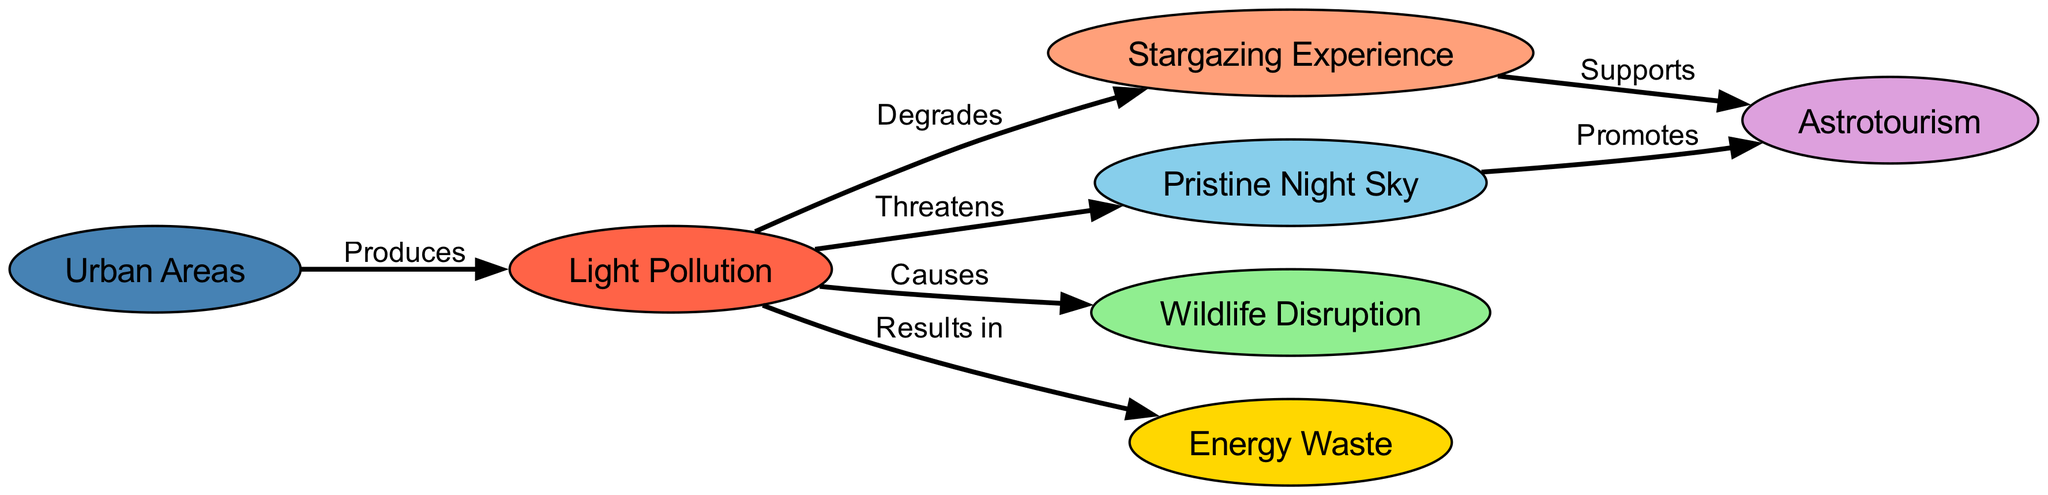What produces light pollution? The diagram indicates that urban areas produce light pollution, as depicted by the directed edge from "urban_areas" to "light_pollution."
Answer: Urban areas What degrades the stargazing experience? According to the diagram, light pollution directly degrades the stargazing experience, as shown by the edge from "light_pollution" to "stargazing."
Answer: Light pollution How many nodes are in this diagram? The diagram includes seven nodes, which can be counted from the listed elements in the "nodes" section: stargazing, light pollution, urban areas, pristine sky, wildlife, energy waste, and astrotourism.
Answer: Seven What is threatened by light pollution? The diagram shows that the pristine night sky is threatened by light pollution, as indicated by the arrow from "light_pollution" to "pristine_sky."
Answer: Pristine night sky How does stargazing support astrotourism? The relationship is established in the diagram, where stargazing supports astrotourism, indicated by the directed edge from "stargazing" to "astrotourism." This implies that improving the stargazing experience contributes positively to astrotourism activities.
Answer: Supports What does light pollution cause in wildlife? The diagram illustrates that light pollution causes wildlife disruption, as evident from the edge leading from "light_pollution" to "wildlife."
Answer: Wildlife disruption What promotes astrotourism? The diagram indicates that a pristine night sky promotes astrotourism, which is represented by the edge from "pristine_sky" to "astrotourism."
Answer: Pristine night sky What results in energy waste? The directed edge from "light_pollution" to "energy_waste" in the diagram indicates that light pollution results in energy waste.
Answer: Light pollution 